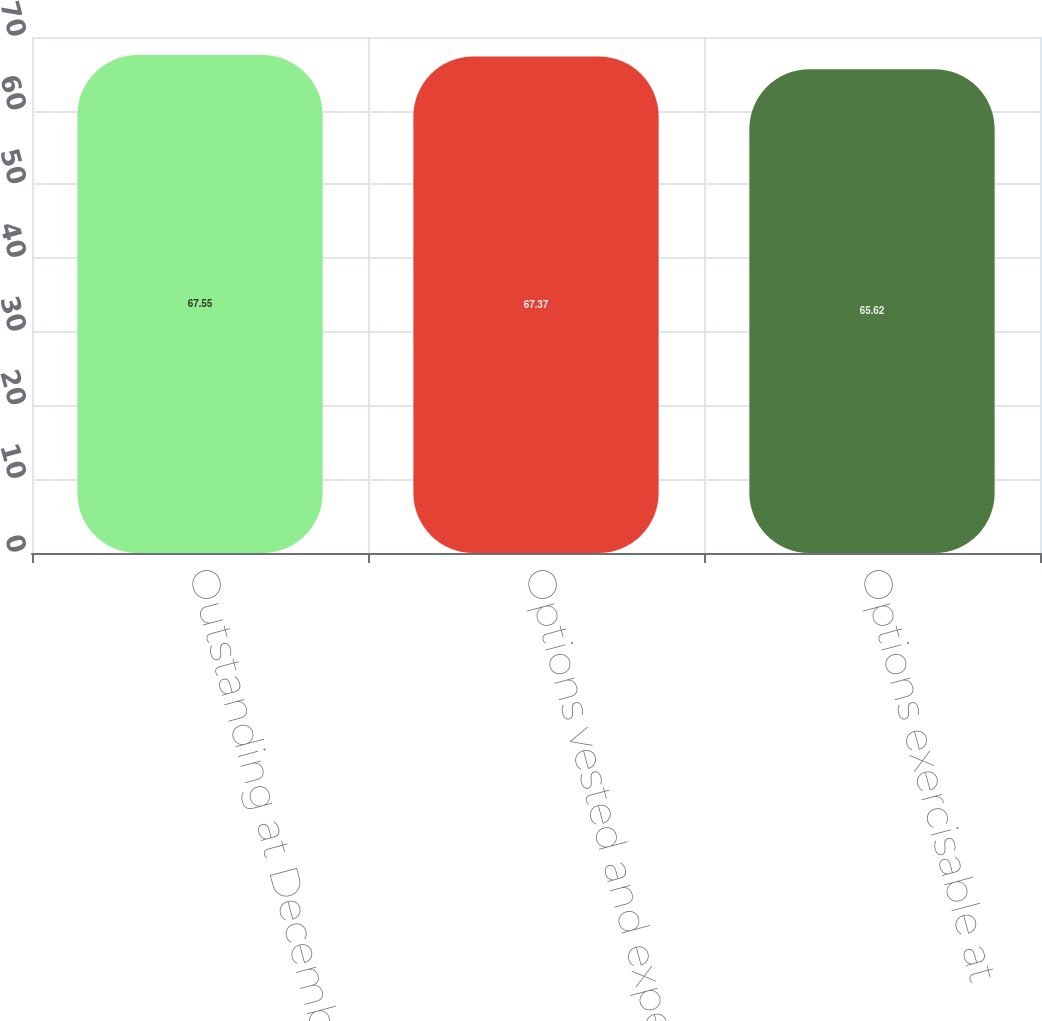Convert chart. <chart><loc_0><loc_0><loc_500><loc_500><bar_chart><fcel>Outstanding at December 31<fcel>Options vested and expected to<fcel>Options exercisable at<nl><fcel>67.55<fcel>67.37<fcel>65.62<nl></chart> 